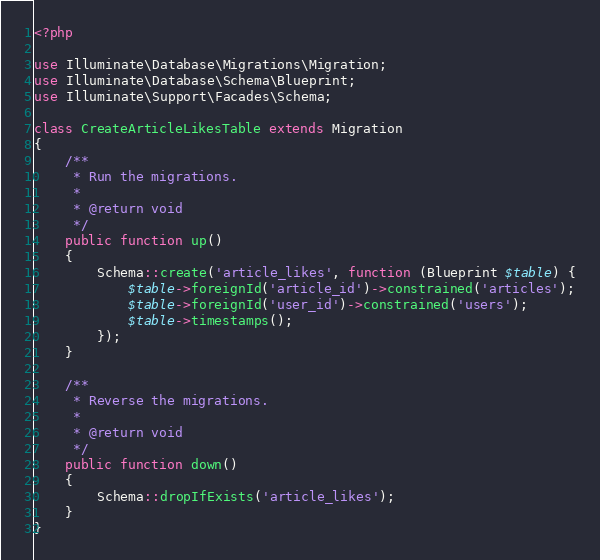<code> <loc_0><loc_0><loc_500><loc_500><_PHP_><?php

use Illuminate\Database\Migrations\Migration;
use Illuminate\Database\Schema\Blueprint;
use Illuminate\Support\Facades\Schema;

class CreateArticleLikesTable extends Migration
{
    /**
     * Run the migrations.
     *
     * @return void
     */
    public function up()
    {
        Schema::create('article_likes', function (Blueprint $table) {
            $table->foreignId('article_id')->constrained('articles');
            $table->foreignId('user_id')->constrained('users');
            $table->timestamps();
        });
    }

    /**
     * Reverse the migrations.
     *
     * @return void
     */
    public function down()
    {
        Schema::dropIfExists('article_likes');
    }
}
</code> 